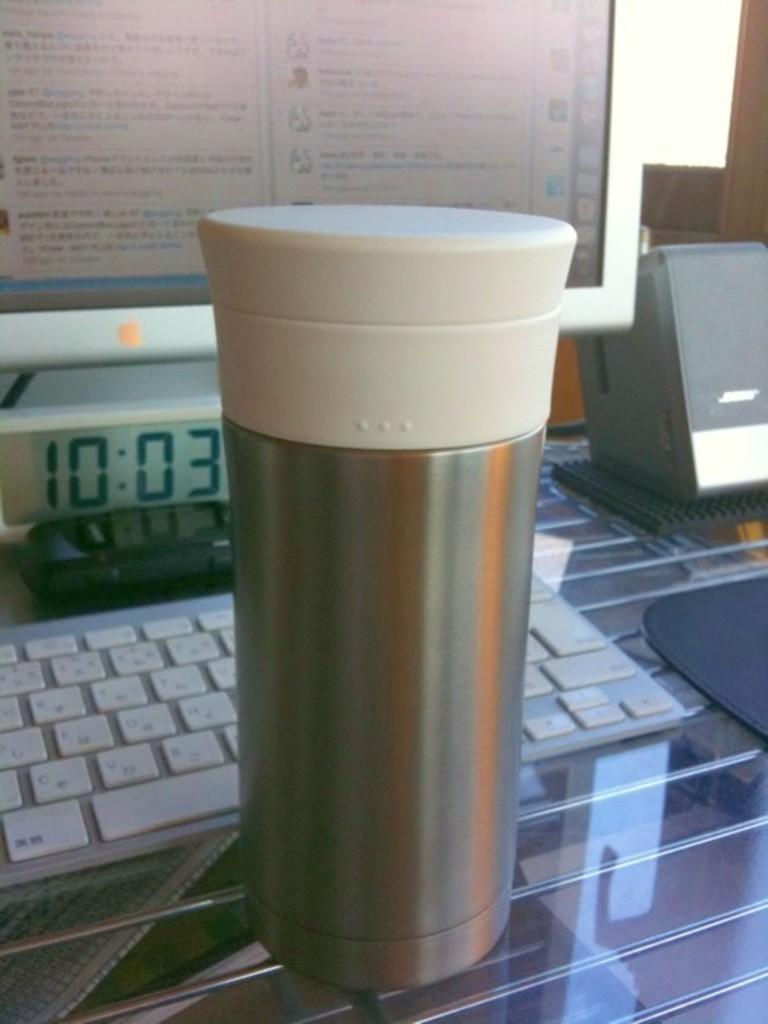<image>
Write a terse but informative summary of the picture. A thermal sits on a table in front of a keyboard and monitor at 10:03. 